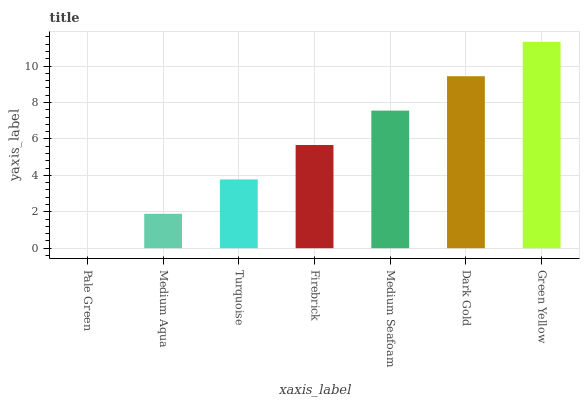Is Pale Green the minimum?
Answer yes or no. Yes. Is Green Yellow the maximum?
Answer yes or no. Yes. Is Medium Aqua the minimum?
Answer yes or no. No. Is Medium Aqua the maximum?
Answer yes or no. No. Is Medium Aqua greater than Pale Green?
Answer yes or no. Yes. Is Pale Green less than Medium Aqua?
Answer yes or no. Yes. Is Pale Green greater than Medium Aqua?
Answer yes or no. No. Is Medium Aqua less than Pale Green?
Answer yes or no. No. Is Firebrick the high median?
Answer yes or no. Yes. Is Firebrick the low median?
Answer yes or no. Yes. Is Green Yellow the high median?
Answer yes or no. No. Is Turquoise the low median?
Answer yes or no. No. 